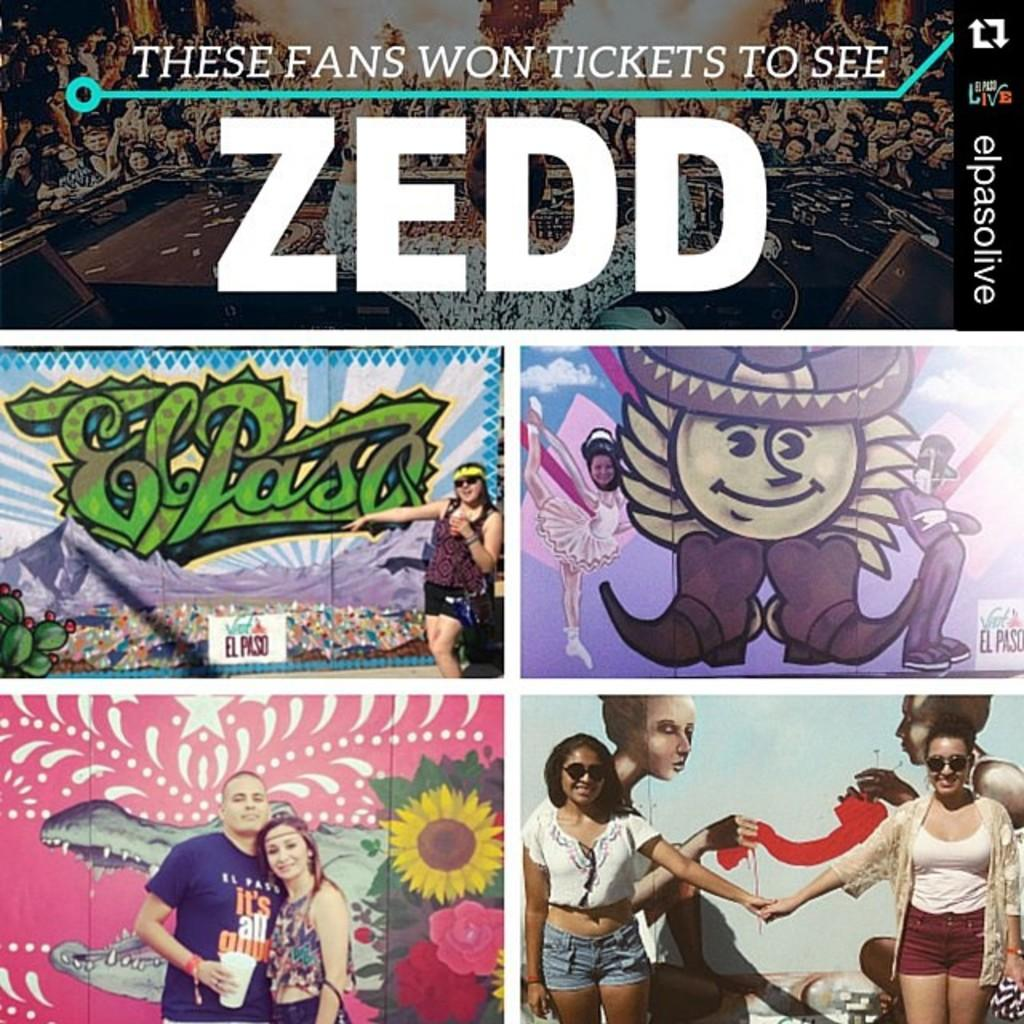<image>
Provide a brief description of the given image. some music that is for an artist named Zedd 